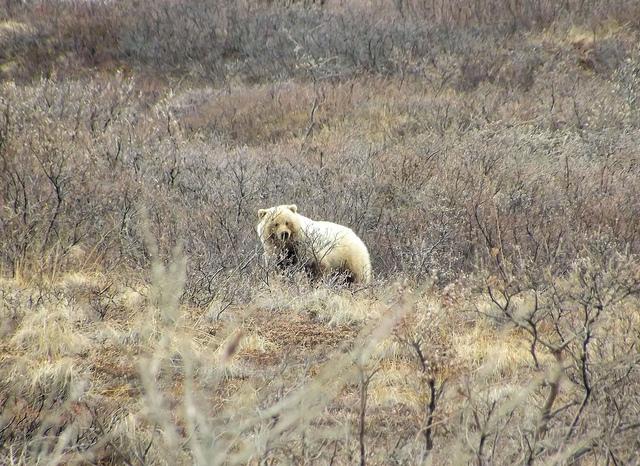What type of bear is in the image?
Quick response, please. Grizzly. What color is the fur on this bear?
Answer briefly. White. What color is the bear?
Concise answer only. Brown. Can this animal naturally camouflage with its environment?
Quick response, please. Yes. 